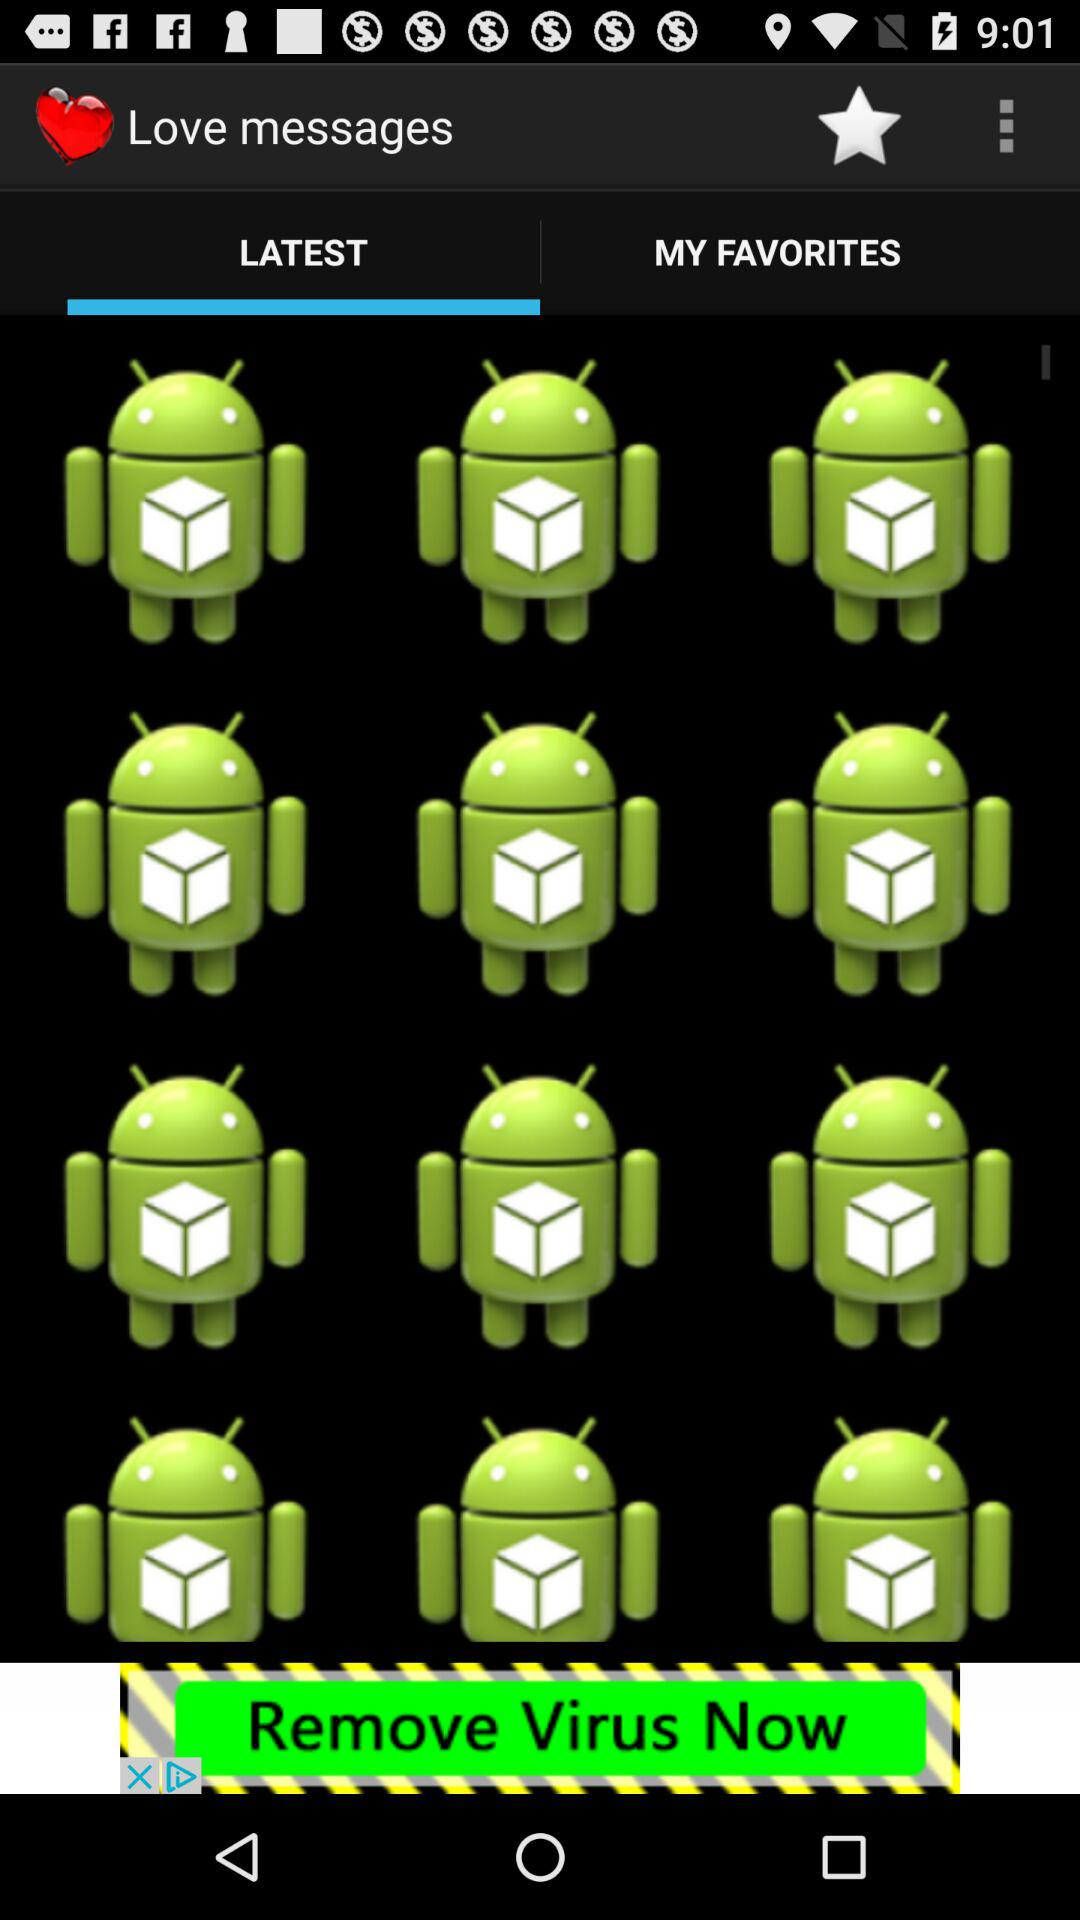Which tab is selected? The selected tab is "LATEST". 